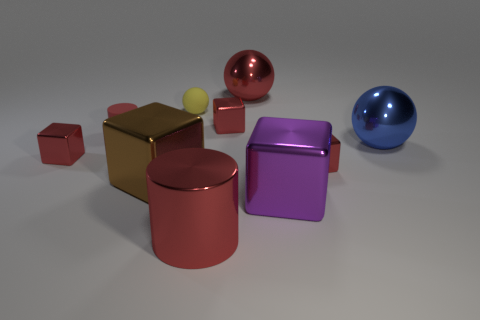Subtract all cylinders. How many objects are left? 8 Subtract all big spheres. How many spheres are left? 1 Subtract 1 cylinders. How many cylinders are left? 1 Subtract all red balls. How many balls are left? 2 Subtract 0 green blocks. How many objects are left? 10 Subtract all brown cubes. Subtract all yellow balls. How many cubes are left? 4 Subtract all cyan cubes. How many yellow cylinders are left? 0 Subtract all tiny green matte balls. Subtract all red blocks. How many objects are left? 7 Add 9 large red spheres. How many large red spheres are left? 10 Add 1 large blue things. How many large blue things exist? 2 